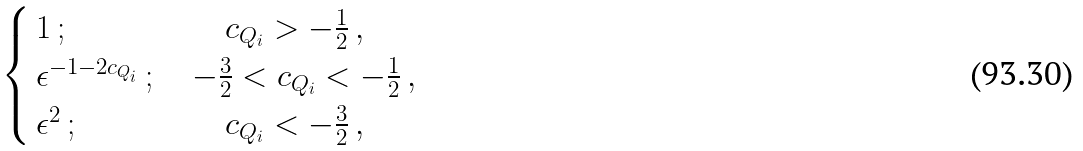Convert formula to latex. <formula><loc_0><loc_0><loc_500><loc_500>\begin{cases} \, 1 \, ; & \, \quad c _ { Q _ { i } } > - \frac { 1 } { 2 } \, , \\ \, \epsilon ^ { - 1 - 2 c _ { Q _ { i } } } \, ; & \, - \frac { 3 } { 2 } < c _ { Q _ { i } } < - \frac { 1 } { 2 } \, , \\ \, \epsilon ^ { 2 } \, ; & \, \quad c _ { Q _ { i } } < - \frac { 3 } { 2 } \, , \end{cases}</formula> 